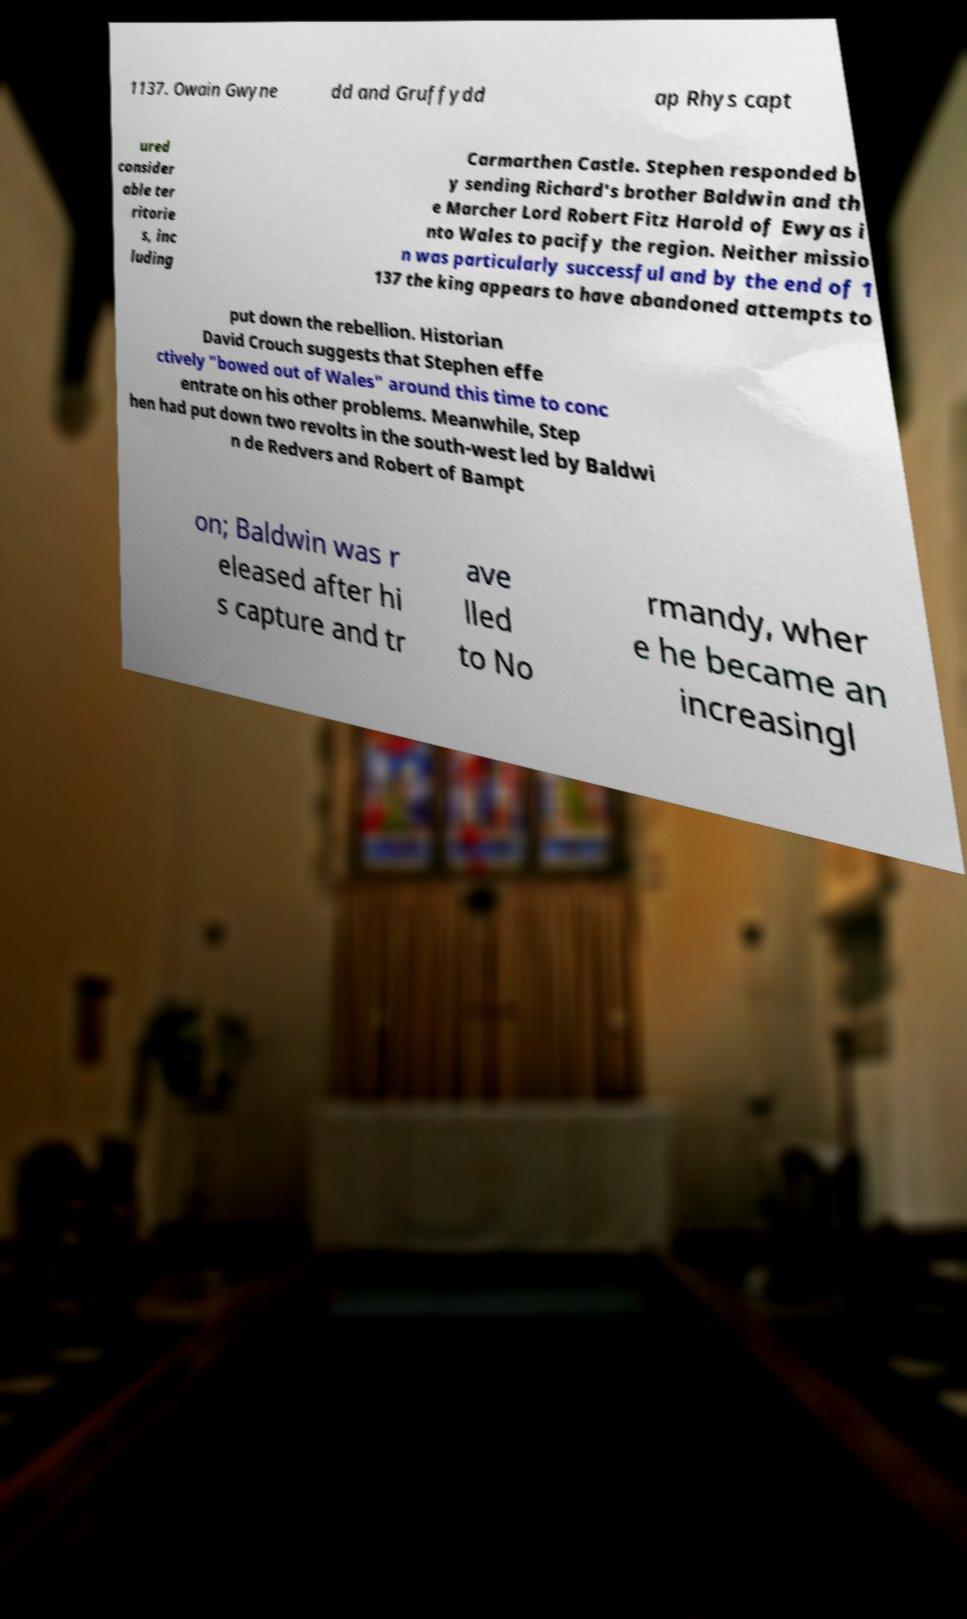Please read and relay the text visible in this image. What does it say? 1137. Owain Gwyne dd and Gruffydd ap Rhys capt ured consider able ter ritorie s, inc luding Carmarthen Castle. Stephen responded b y sending Richard's brother Baldwin and th e Marcher Lord Robert Fitz Harold of Ewyas i nto Wales to pacify the region. Neither missio n was particularly successful and by the end of 1 137 the king appears to have abandoned attempts to put down the rebellion. Historian David Crouch suggests that Stephen effe ctively "bowed out of Wales" around this time to conc entrate on his other problems. Meanwhile, Step hen had put down two revolts in the south-west led by Baldwi n de Redvers and Robert of Bampt on; Baldwin was r eleased after hi s capture and tr ave lled to No rmandy, wher e he became an increasingl 